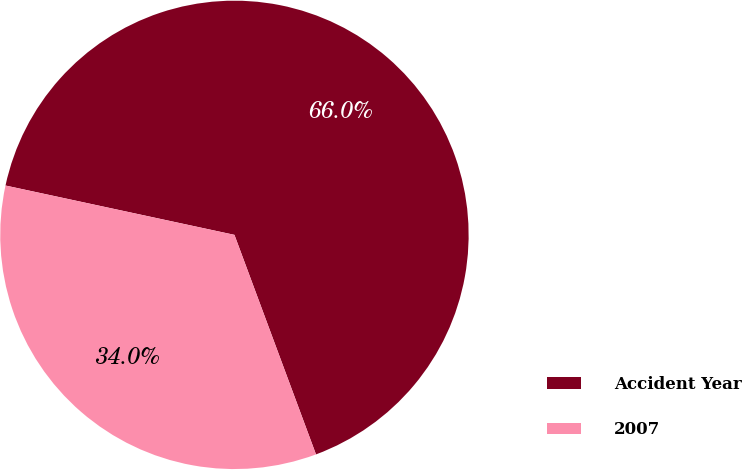<chart> <loc_0><loc_0><loc_500><loc_500><pie_chart><fcel>Accident Year<fcel>2007<nl><fcel>65.96%<fcel>34.04%<nl></chart> 